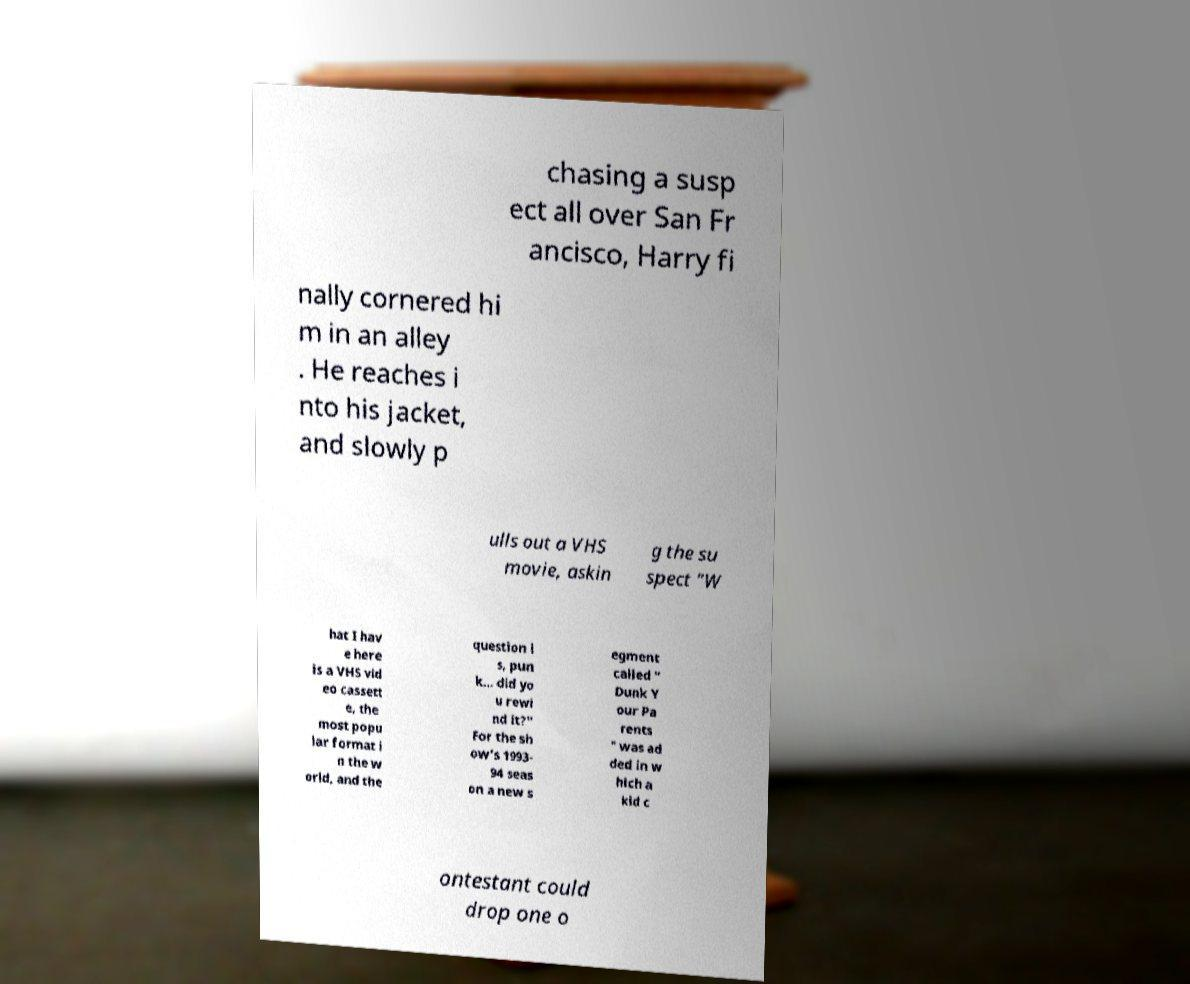Please identify and transcribe the text found in this image. chasing a susp ect all over San Fr ancisco, Harry fi nally cornered hi m in an alley . He reaches i nto his jacket, and slowly p ulls out a VHS movie, askin g the su spect "W hat I hav e here is a VHS vid eo cassett e, the most popu lar format i n the w orld, and the question i s, pun k... did yo u rewi nd it?" For the sh ow's 1993- 94 seas on a new s egment called " Dunk Y our Pa rents " was ad ded in w hich a kid c ontestant could drop one o 